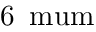Convert formula to latex. <formula><loc_0><loc_0><loc_500><loc_500>6 \, \ m u m</formula> 